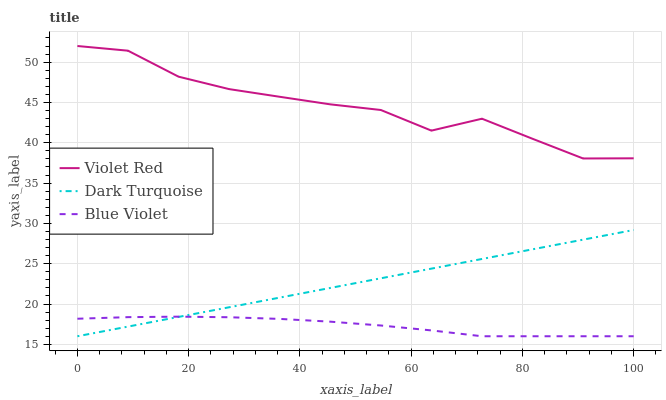Does Blue Violet have the minimum area under the curve?
Answer yes or no. Yes. Does Violet Red have the maximum area under the curve?
Answer yes or no. Yes. Does Violet Red have the minimum area under the curve?
Answer yes or no. No. Does Blue Violet have the maximum area under the curve?
Answer yes or no. No. Is Dark Turquoise the smoothest?
Answer yes or no. Yes. Is Violet Red the roughest?
Answer yes or no. Yes. Is Blue Violet the smoothest?
Answer yes or no. No. Is Blue Violet the roughest?
Answer yes or no. No. Does Violet Red have the lowest value?
Answer yes or no. No. Does Violet Red have the highest value?
Answer yes or no. Yes. Does Blue Violet have the highest value?
Answer yes or no. No. Is Blue Violet less than Violet Red?
Answer yes or no. Yes. Is Violet Red greater than Blue Violet?
Answer yes or no. Yes. Does Blue Violet intersect Dark Turquoise?
Answer yes or no. Yes. Is Blue Violet less than Dark Turquoise?
Answer yes or no. No. Is Blue Violet greater than Dark Turquoise?
Answer yes or no. No. Does Blue Violet intersect Violet Red?
Answer yes or no. No. 